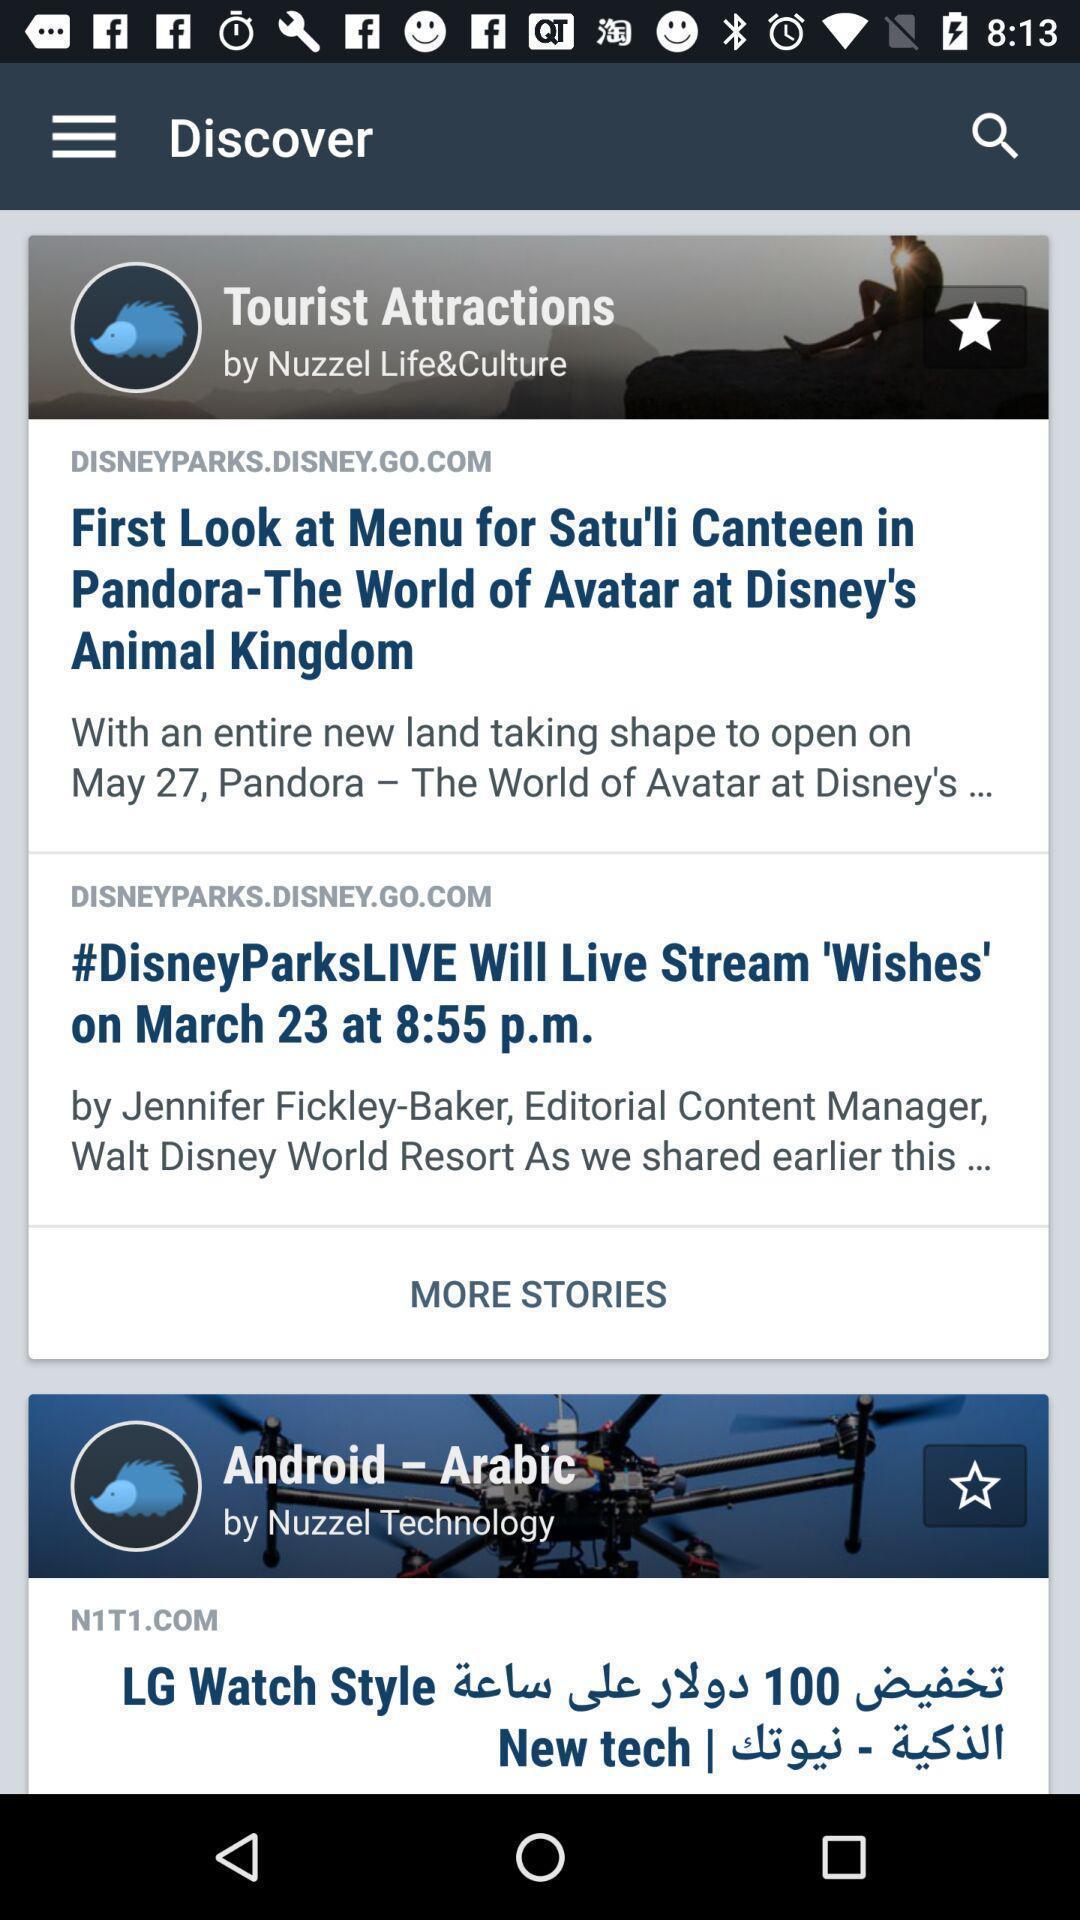Describe the key features of this screenshot. Screen displaying multiple articles in discover page. 